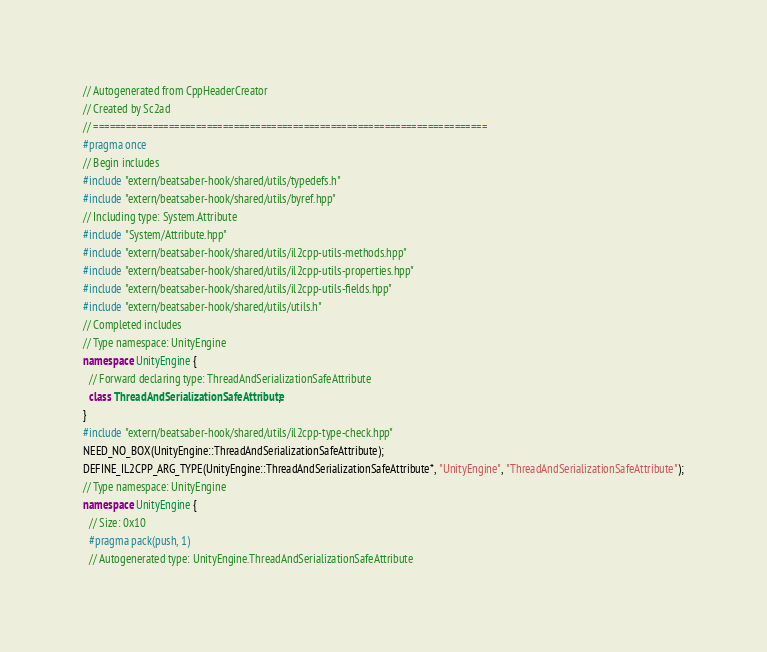<code> <loc_0><loc_0><loc_500><loc_500><_C++_>// Autogenerated from CppHeaderCreator
// Created by Sc2ad
// =========================================================================
#pragma once
// Begin includes
#include "extern/beatsaber-hook/shared/utils/typedefs.h"
#include "extern/beatsaber-hook/shared/utils/byref.hpp"
// Including type: System.Attribute
#include "System/Attribute.hpp"
#include "extern/beatsaber-hook/shared/utils/il2cpp-utils-methods.hpp"
#include "extern/beatsaber-hook/shared/utils/il2cpp-utils-properties.hpp"
#include "extern/beatsaber-hook/shared/utils/il2cpp-utils-fields.hpp"
#include "extern/beatsaber-hook/shared/utils/utils.h"
// Completed includes
// Type namespace: UnityEngine
namespace UnityEngine {
  // Forward declaring type: ThreadAndSerializationSafeAttribute
  class ThreadAndSerializationSafeAttribute;
}
#include "extern/beatsaber-hook/shared/utils/il2cpp-type-check.hpp"
NEED_NO_BOX(UnityEngine::ThreadAndSerializationSafeAttribute);
DEFINE_IL2CPP_ARG_TYPE(UnityEngine::ThreadAndSerializationSafeAttribute*, "UnityEngine", "ThreadAndSerializationSafeAttribute");
// Type namespace: UnityEngine
namespace UnityEngine {
  // Size: 0x10
  #pragma pack(push, 1)
  // Autogenerated type: UnityEngine.ThreadAndSerializationSafeAttribute</code> 